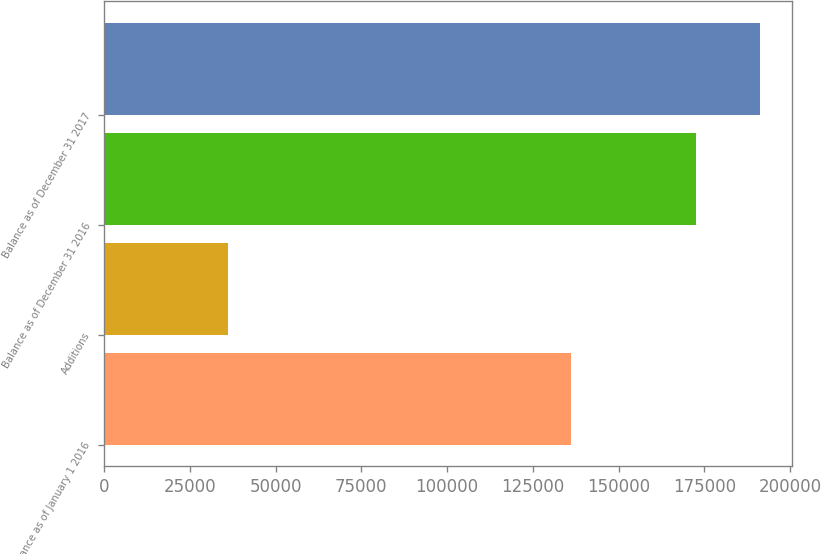Convert chart. <chart><loc_0><loc_0><loc_500><loc_500><bar_chart><fcel>Balance as of January 1 2016<fcel>Additions<fcel>Balance as of December 31 2016<fcel>Balance as of December 31 2017<nl><fcel>136079<fcel>36267<fcel>172593<fcel>191091<nl></chart> 